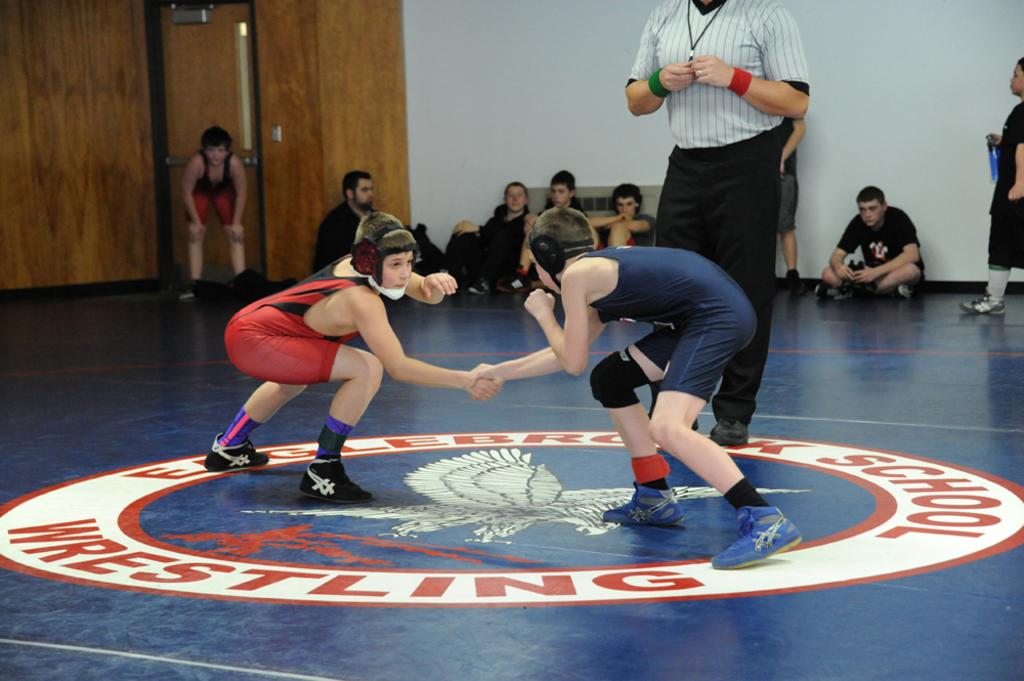What does it say on the circle on the floor?
Offer a terse response. Wrestling. 